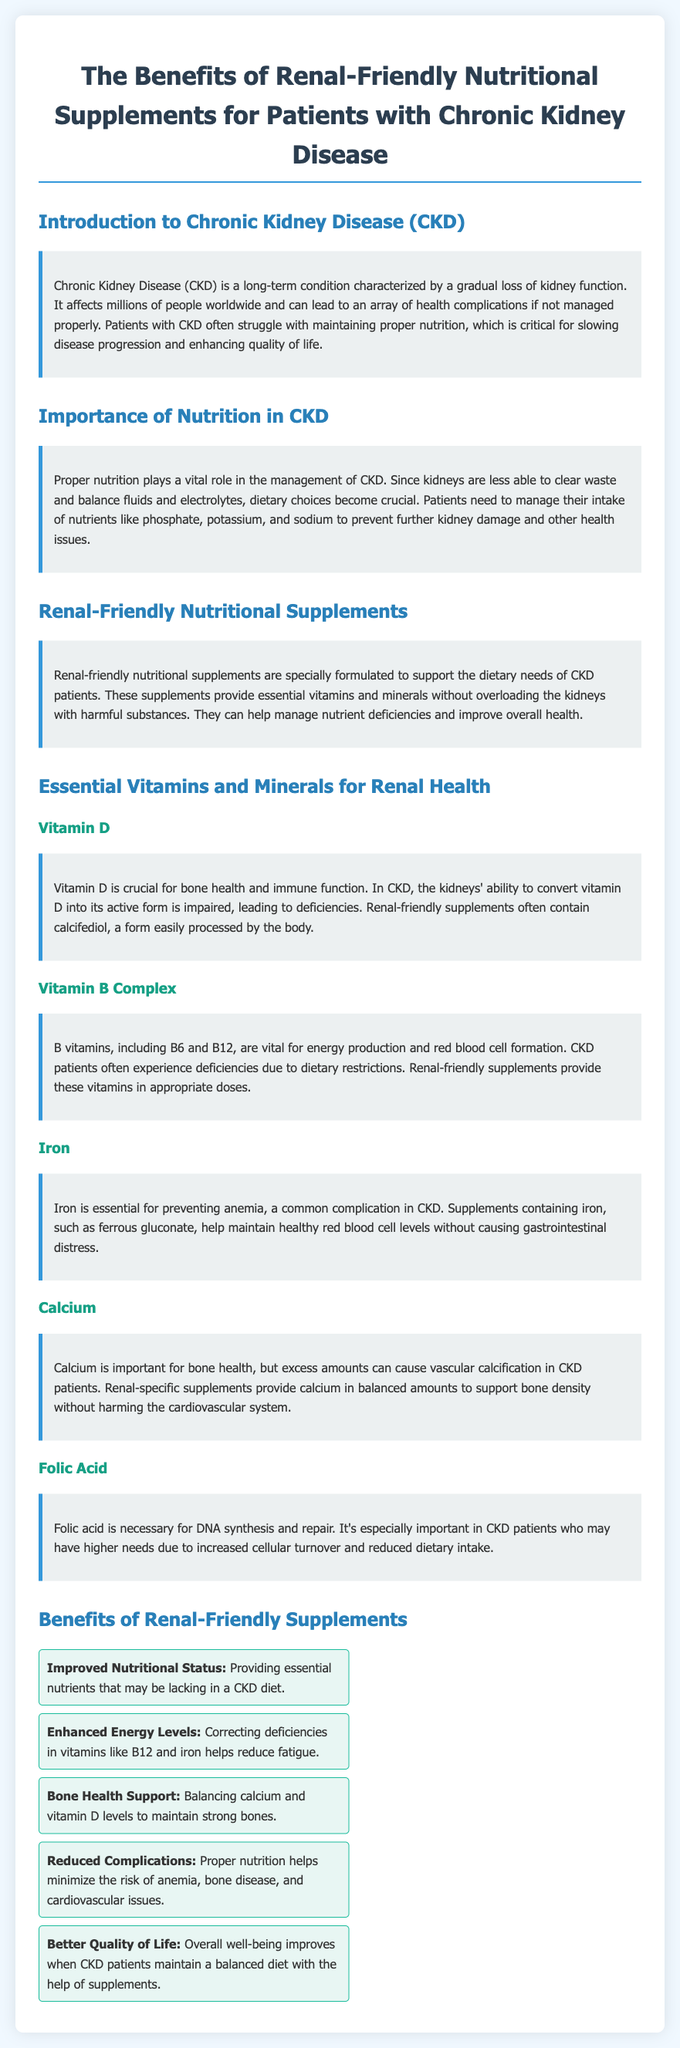What is chronic kidney disease? The document describes chronic kidney disease (CKD) as a long-term condition characterized by a gradual loss of kidney function.
Answer: A long-term condition What is a benefit of renal-friendly supplements regarding energy levels? The document states that correcting deficiencies in vitamins like B12 and iron helps reduce fatigue.
Answer: Enhanced Energy Levels Which vitamin is crucial for bone health? The document mentions Vitamin D as crucial for bone health and immune function.
Answer: Vitamin D What essential mineral helps prevent anemia? The document states that iron is essential for preventing anemia.
Answer: Iron What is the importance of nutrition in CKD? The document explains that proper nutrition is vital for managing CKD, as dietary choices become crucial.
Answer: Vital for management What vitamin complex is mentioned for energy production? The document refers to Vitamin B Complex, including B6 and B12, as vital for energy production.
Answer: Vitamin B Complex How do renal-friendly supplements help with nutritional status? The document states they provide essential nutrients that may be lacking in a CKD diet.
Answer: Improved Nutritional Status Which mineral is balanced to support bone density in CKD patients? The document specifies that calcium is provided in balanced amounts to support bone density.
Answer: Calcium What is one of the goals of renal-friendly supplements? The document mentions that a goal is to improve overall well-being through balanced diet support.
Answer: Better Quality of Life 